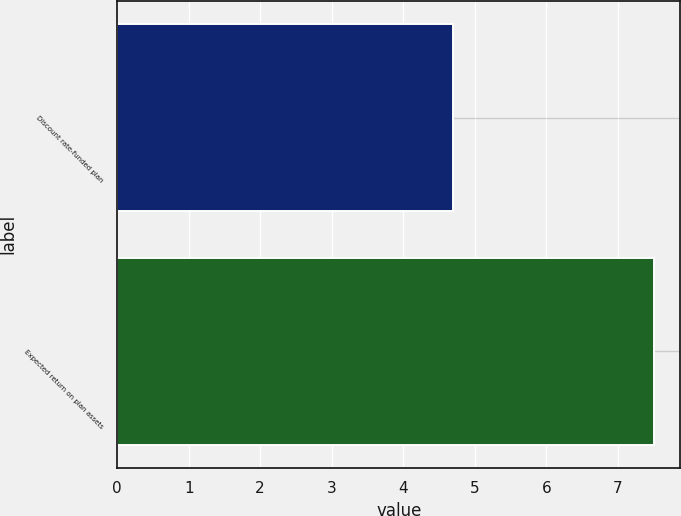Convert chart. <chart><loc_0><loc_0><loc_500><loc_500><bar_chart><fcel>Discount rate-funded plan<fcel>Expected return on plan assets<nl><fcel>4.7<fcel>7.5<nl></chart> 